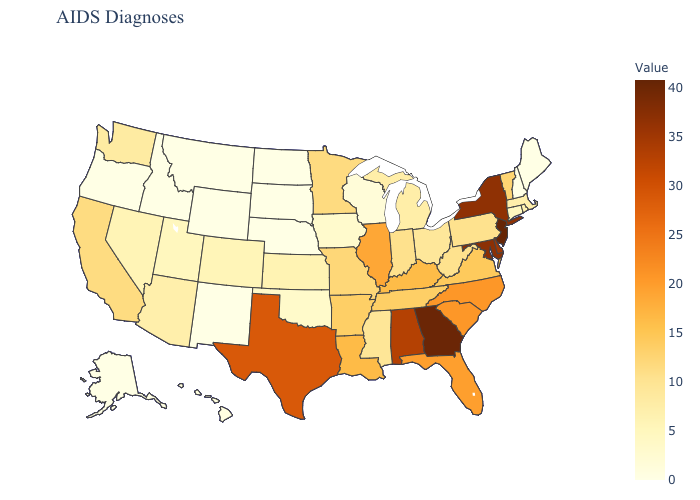Which states have the highest value in the USA?
Concise answer only. New Jersey. Which states have the highest value in the USA?
Short answer required. New Jersey. Does North Carolina have the lowest value in the South?
Write a very short answer. No. Among the states that border Texas , which have the lowest value?
Write a very short answer. New Mexico. Which states have the highest value in the USA?
Write a very short answer. New Jersey. Does New Jersey have the highest value in the USA?
Short answer required. Yes. Which states have the lowest value in the Northeast?
Short answer required. Maine, New Hampshire. Which states have the lowest value in the West?
Keep it brief. Alaska, Idaho, Montana, New Mexico, Oregon, Wyoming. 